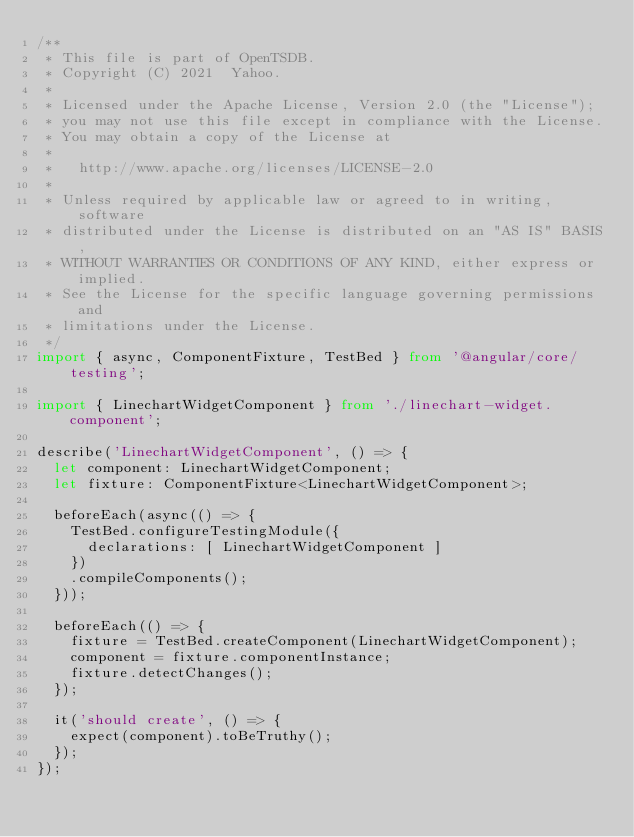<code> <loc_0><loc_0><loc_500><loc_500><_TypeScript_>/**
 * This file is part of OpenTSDB.
 * Copyright (C) 2021  Yahoo.
 *
 * Licensed under the Apache License, Version 2.0 (the "License");
 * you may not use this file except in compliance with the License.
 * You may obtain a copy of the License at
 *
 *   http://www.apache.org/licenses/LICENSE-2.0
 *
 * Unless required by applicable law or agreed to in writing, software
 * distributed under the License is distributed on an "AS IS" BASIS,
 * WITHOUT WARRANTIES OR CONDITIONS OF ANY KIND, either express or implied.
 * See the License for the specific language governing permissions and
 * limitations under the License.
 */
import { async, ComponentFixture, TestBed } from '@angular/core/testing';

import { LinechartWidgetComponent } from './linechart-widget.component';

describe('LinechartWidgetComponent', () => {
  let component: LinechartWidgetComponent;
  let fixture: ComponentFixture<LinechartWidgetComponent>;

  beforeEach(async(() => {
    TestBed.configureTestingModule({
      declarations: [ LinechartWidgetComponent ]
    })
    .compileComponents();
  }));

  beforeEach(() => {
    fixture = TestBed.createComponent(LinechartWidgetComponent);
    component = fixture.componentInstance;
    fixture.detectChanges();
  });

  it('should create', () => {
    expect(component).toBeTruthy();
  });
});
</code> 